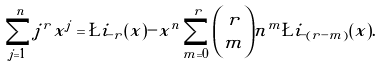Convert formula to latex. <formula><loc_0><loc_0><loc_500><loc_500>\sum _ { j = 1 } ^ { n } j ^ { r } x ^ { j } = \L i _ { - r } ( x ) - x ^ { n } \sum _ { m = 0 } ^ { r } { r \choose m } n ^ { m } \L i _ { - ( r - m ) } ( x ) .</formula> 